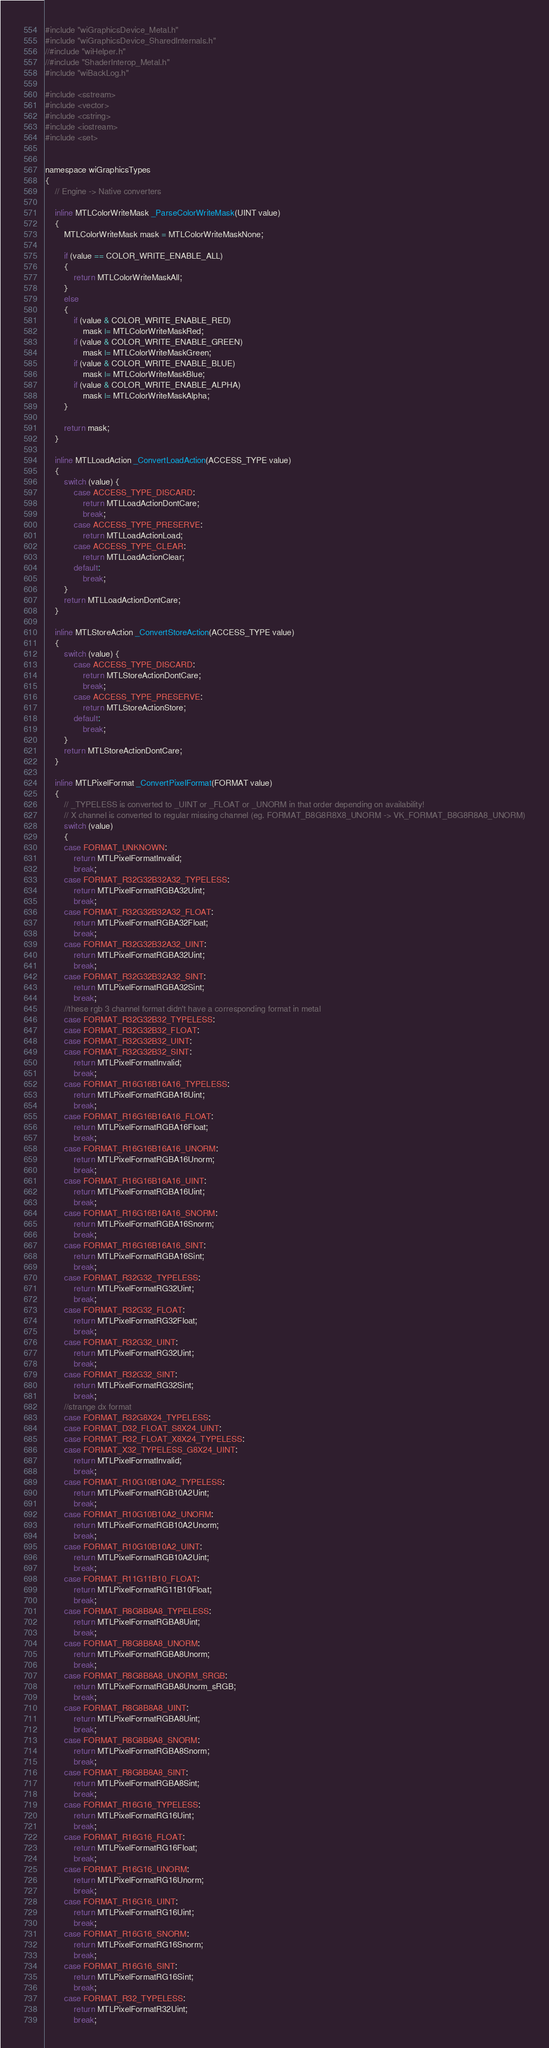Convert code to text. <code><loc_0><loc_0><loc_500><loc_500><_ObjectiveC_>#include "wiGraphicsDevice_Metal.h"
#include "wiGraphicsDevice_SharedInternals.h"
//#include "wiHelper.h"
//#include "ShaderInterop_Metal.h"
#include "wiBackLog.h"

#include <sstream>
#include <vector>
#include <cstring>
#include <iostream>
#include <set>


namespace wiGraphicsTypes
{
    // Engine -> Native converters

    inline MTLColorWriteMask _ParseColorWriteMask(UINT value)
    {
        MTLColorWriteMask mask = MTLColorWriteMaskNone;
        
        if (value == COLOR_WRITE_ENABLE_ALL)
        {
            return MTLColorWriteMaskAll;
        }
        else
        {
            if (value & COLOR_WRITE_ENABLE_RED)
                mask |= MTLColorWriteMaskRed;
            if (value & COLOR_WRITE_ENABLE_GREEN)
                mask |= MTLColorWriteMaskGreen;
            if (value & COLOR_WRITE_ENABLE_BLUE)
                mask |= MTLColorWriteMaskBlue;
            if (value & COLOR_WRITE_ENABLE_ALPHA)
                mask |= MTLColorWriteMaskAlpha;
        }
        
        return mask;
    }
    
    inline MTLLoadAction _ConvertLoadAction(ACCESS_TYPE value)
    {
        switch (value) {
            case ACCESS_TYPE_DISCARD:
                return MTLLoadActionDontCare;
                break;
            case ACCESS_TYPE_PRESERVE:
                return MTLLoadActionLoad;
            case ACCESS_TYPE_CLEAR:
                return MTLLoadActionClear;
            default:
                break;
        }
        return MTLLoadActionDontCare;
    }
    
    inline MTLStoreAction _ConvertStoreAction(ACCESS_TYPE value)
    {
        switch (value) {
            case ACCESS_TYPE_DISCARD:
                return MTLStoreActionDontCare;
                break;
            case ACCESS_TYPE_PRESERVE:
                return MTLStoreActionStore;
            default:
                break;
        }
        return MTLStoreActionDontCare;
    }
    
	inline MTLPixelFormat _ConvertPixelFormat(FORMAT value)
	{
		// _TYPELESS is converted to _UINT or _FLOAT or _UNORM in that order depending on availability!
		// X channel is converted to regular missing channel (eg. FORMAT_B8G8R8X8_UNORM -> VK_FORMAT_B8G8R8A8_UNORM)
		switch (value)
		{
		case FORMAT_UNKNOWN:
			return MTLPixelFormatInvalid;
			break;
        case FORMAT_R32G32B32A32_TYPELESS:
            return MTLPixelFormatRGBA32Uint;
            break;
        case FORMAT_R32G32B32A32_FLOAT:
            return MTLPixelFormatRGBA32Float;
            break;
        case FORMAT_R32G32B32A32_UINT:
            return MTLPixelFormatRGBA32Uint;
            break;
        case FORMAT_R32G32B32A32_SINT:
            return MTLPixelFormatRGBA32Sint;
            break;
        //these rgb 3 channel format didn't have a corresponding format in metal
        case FORMAT_R32G32B32_TYPELESS:
        case FORMAT_R32G32B32_FLOAT:
        case FORMAT_R32G32B32_UINT:
        case FORMAT_R32G32B32_SINT:
            return MTLPixelFormatInvalid;
            break;
        case FORMAT_R16G16B16A16_TYPELESS:
            return MTLPixelFormatRGBA16Uint;
            break;
        case FORMAT_R16G16B16A16_FLOAT:
            return MTLPixelFormatRGBA16Float;
            break;
        case FORMAT_R16G16B16A16_UNORM:
            return MTLPixelFormatRGBA16Unorm;
            break;
        case FORMAT_R16G16B16A16_UINT:
            return MTLPixelFormatRGBA16Uint;
            break;
        case FORMAT_R16G16B16A16_SNORM:
            return MTLPixelFormatRGBA16Snorm;
            break;
        case FORMAT_R16G16B16A16_SINT:
            return MTLPixelFormatRGBA16Sint;
            break;
        case FORMAT_R32G32_TYPELESS:
            return MTLPixelFormatRG32Uint;
            break;
        case FORMAT_R32G32_FLOAT:
            return MTLPixelFormatRG32Float;
            break;
        case FORMAT_R32G32_UINT:
            return MTLPixelFormatRG32Uint;
            break;
        case FORMAT_R32G32_SINT:
            return MTLPixelFormatRG32Sint;
            break;
        //strange dx format
        case FORMAT_R32G8X24_TYPELESS:
        case FORMAT_D32_FLOAT_S8X24_UINT:
        case FORMAT_R32_FLOAT_X8X24_TYPELESS:
        case FORMAT_X32_TYPELESS_G8X24_UINT:
            return MTLPixelFormatInvalid;
            break;
        case FORMAT_R10G10B10A2_TYPELESS:
            return MTLPixelFormatRGB10A2Uint;
            break;
        case FORMAT_R10G10B10A2_UNORM:
            return MTLPixelFormatRGB10A2Unorm;
            break;
        case FORMAT_R10G10B10A2_UINT:
            return MTLPixelFormatRGB10A2Uint;
            break;
        case FORMAT_R11G11B10_FLOAT:
            return MTLPixelFormatRG11B10Float;
            break;
        case FORMAT_R8G8B8A8_TYPELESS:
            return MTLPixelFormatRGBA8Uint;
            break;
        case FORMAT_R8G8B8A8_UNORM:
            return MTLPixelFormatRGBA8Unorm;
            break;
        case FORMAT_R8G8B8A8_UNORM_SRGB:
            return MTLPixelFormatRGBA8Unorm_sRGB;
            break;
        case FORMAT_R8G8B8A8_UINT:
            return MTLPixelFormatRGBA8Uint;
            break;
        case FORMAT_R8G8B8A8_SNORM:
            return MTLPixelFormatRGBA8Snorm;
            break;
        case FORMAT_R8G8B8A8_SINT:
            return MTLPixelFormatRGBA8Sint;
            break;
        case FORMAT_R16G16_TYPELESS:
            return MTLPixelFormatRG16Uint;
            break;
        case FORMAT_R16G16_FLOAT:
            return MTLPixelFormatRG16Float;
            break;
        case FORMAT_R16G16_UNORM:
            return MTLPixelFormatRG16Unorm;
            break;
        case FORMAT_R16G16_UINT:
            return MTLPixelFormatRG16Uint;
            break;
        case FORMAT_R16G16_SNORM:
            return MTLPixelFormatRG16Snorm;
            break;
        case FORMAT_R16G16_SINT:
            return MTLPixelFormatRG16Sint;
            break;
        case FORMAT_R32_TYPELESS:
            return MTLPixelFormatR32Uint;
            break;</code> 